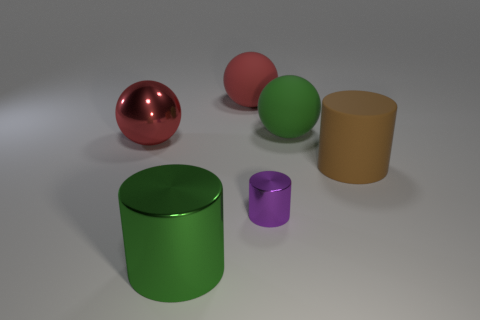Add 4 red metal balls. How many objects exist? 10 Subtract all big red metal spheres. How many spheres are left? 2 Subtract all purple cylinders. How many cylinders are left? 2 Subtract all red cylinders. How many red spheres are left? 2 Subtract 1 green spheres. How many objects are left? 5 Subtract 3 cylinders. How many cylinders are left? 0 Subtract all brown cylinders. Subtract all cyan balls. How many cylinders are left? 2 Subtract all tiny gray balls. Subtract all tiny purple shiny objects. How many objects are left? 5 Add 2 large red rubber spheres. How many large red rubber spheres are left? 3 Add 3 big red matte cubes. How many big red matte cubes exist? 3 